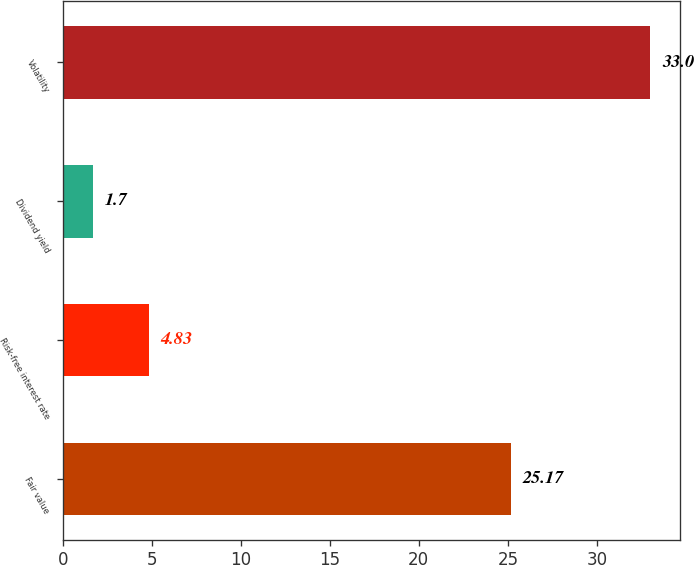<chart> <loc_0><loc_0><loc_500><loc_500><bar_chart><fcel>Fair value<fcel>Risk-free interest rate<fcel>Dividend yield<fcel>Volatility<nl><fcel>25.17<fcel>4.83<fcel>1.7<fcel>33<nl></chart> 